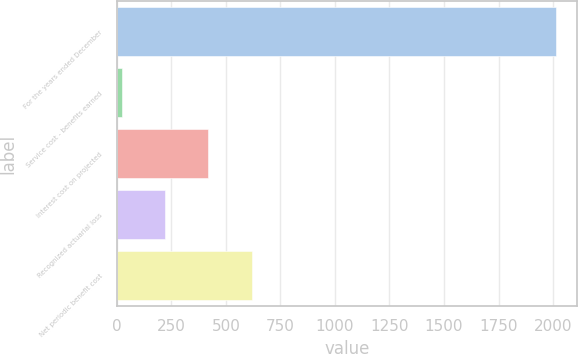Convert chart. <chart><loc_0><loc_0><loc_500><loc_500><bar_chart><fcel>For the years ended December<fcel>Service cost - benefits earned<fcel>Interest cost on projected<fcel>Recognized actuarial loss<fcel>Net periodic benefit cost<nl><fcel>2011<fcel>22<fcel>419.8<fcel>220.9<fcel>618.7<nl></chart> 